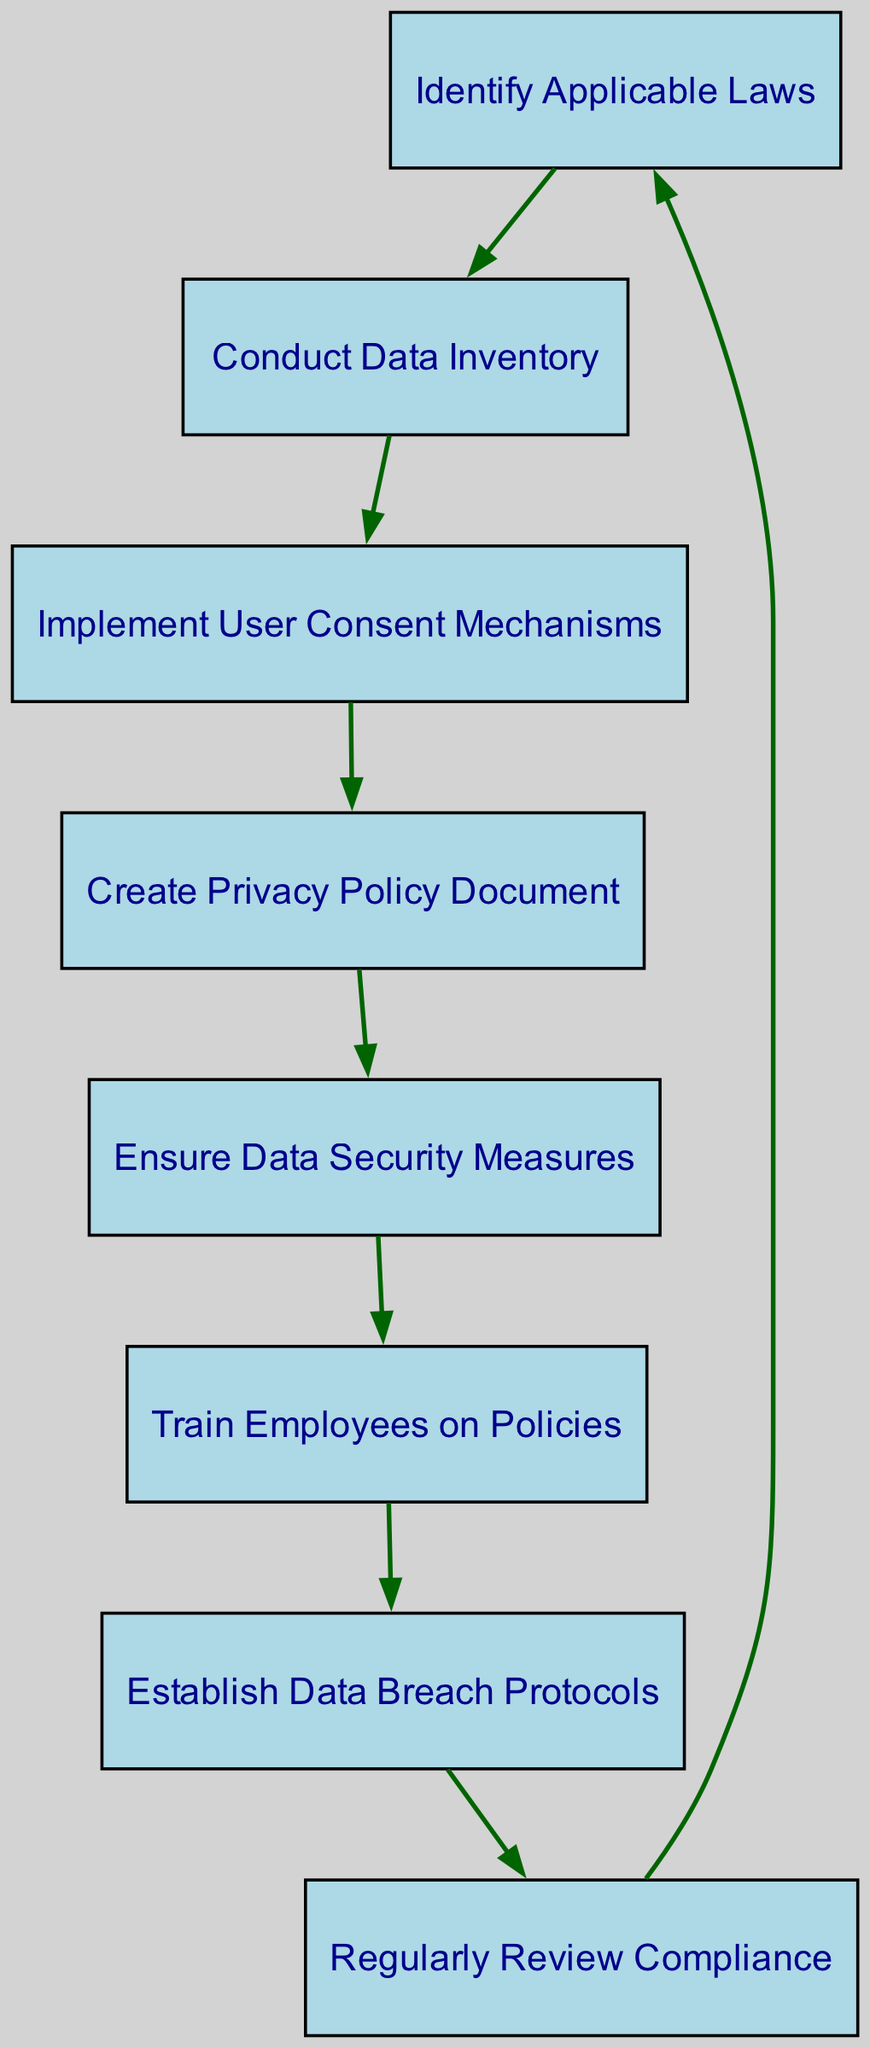What are the first two steps in the compliance process? The first two nodes in the diagram represent the first two steps. The first step is "Identify Applicable Laws" followed by "Conduct Data Inventory."
Answer: Identify Applicable Laws, Conduct Data Inventory How many nodes are present in the diagram? By counting the distinct items in the "nodes" section of the data, there are a total of eight nodes.
Answer: 8 What step follows "Establish Data Breach Protocols"? The diagram indicates a direct connection from "Establish Data Breach Protocols," which is node 7, to the next step "Regularly Review Compliance," which is node 8.
Answer: Regularly Review Compliance What is the last step in this series of compliance steps? The flow proceeds from "Regularly Review Compliance" back to "Identify Applicable Laws," creating a cycle. Since it ends at node 1, that means the last step is "Identify Applicable Laws."
Answer: Identify Applicable Laws What is the relationship between "Implement User Consent Mechanisms" and "Create Privacy Policy Document"? The edge connecting these two nodes shows a direct flow from "Implement User Consent Mechanisms" (node 3) to "Create Privacy Policy Document" (node 4), indicating a sequential relationship.
Answer: Sequential Which step comes after ensuring data security measures? The diagram shows an edge leading from "Ensure Data Security Measures" (node 5) to "Train Employees on Policies" (node 6), indicating that the next step is training employees.
Answer: Train Employees on Policies How many edges are there in the diagram? By examining the "edges" section of the data, we can count that there are seven connections drawn between the nodes.
Answer: 7 What is the primary purpose of the directed graph? The primary purpose represented by the structure of the directed graph is to outline the compliance steps required for privacy policies in a sequential manner.
Answer: Outline compliance steps 